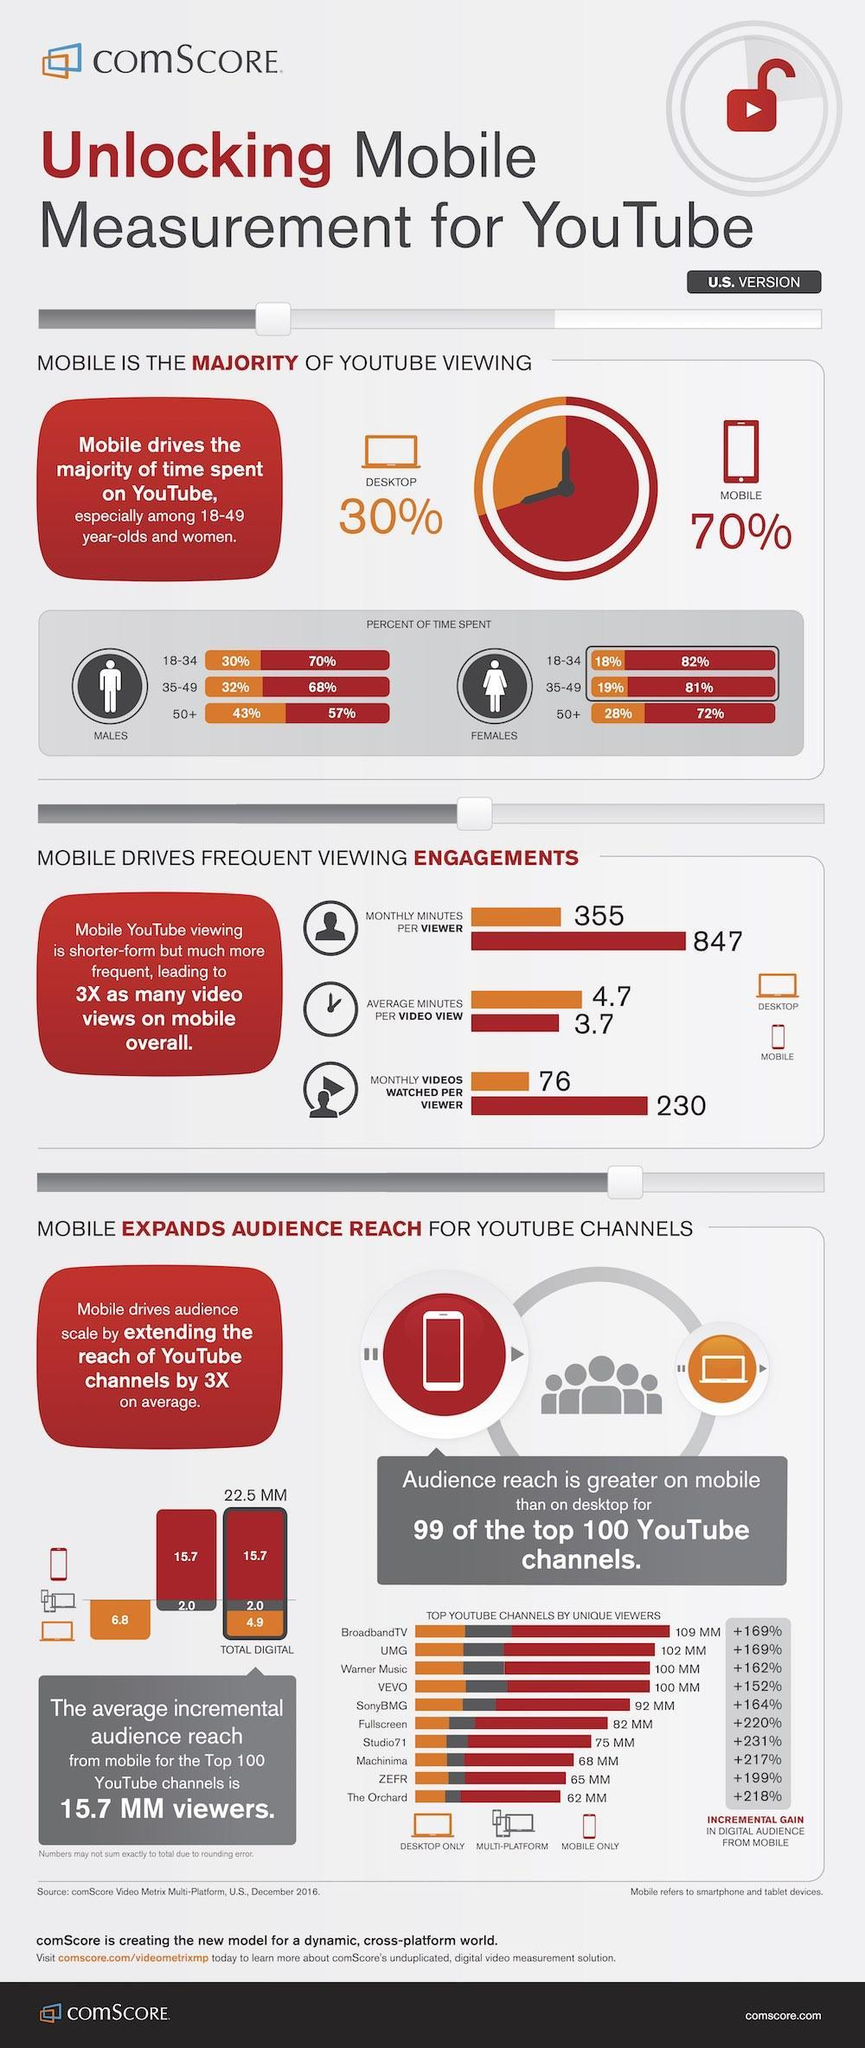Which age group of females in U.S. spent 82% of their time for viewing youtube in the mobile?
Answer the question with a short phrase. 18-34 Which age group of females in U.S. spent least time for youtube viewing in the desktop? 18-34 What percent of time is spent by males in the age group of 18-34  for youtube viewing in U.S.? 30% What is the monthly videos watched per viewer in a mobile in U.S? 230 Which age group of males in U.S. spent more time in youtube viewing in the desktop? 50+ What is the average minutes per video viewed in a desktop in U.S? 4.7 Which age group of males in U.S. spent 57% of their time for viewing youtube in the mobile? 50+ What percent of people uses mobile for youtube viewing in the U.S.? 70% What percent of people uses desktop for youtube viewing in the U.S.? 30% What percent of time is spent by females in the age group of 35-49 for viewing the youtube in U.S. ? 81% 